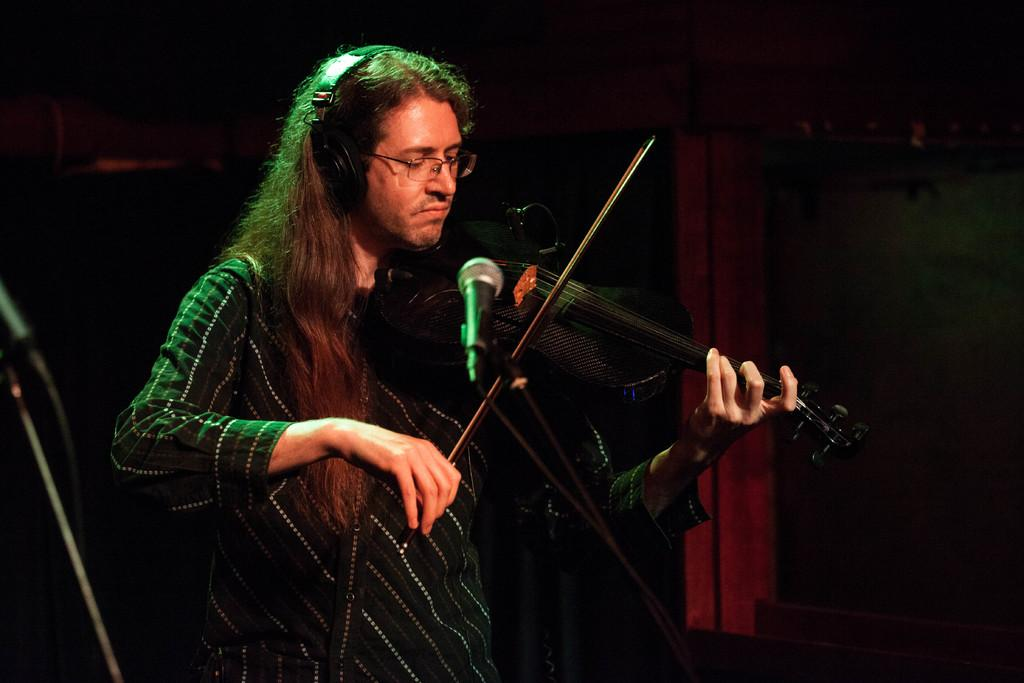What is the person in the image doing? The person is playing the violin in the image. What objects are in the foreground of the image? There are microphones in the foreground of the image. How would you describe the background of the image? The background of the image is dark. What type of glue is being used to hold the wheel in the image? There is no wheel or glue present in the image; it features a person playing the violin and microphones in the foreground. Can you see any waves in the image? There are no waves visible in the image; it is focused on a person playing the violin and microphones in the foreground with a dark background. 